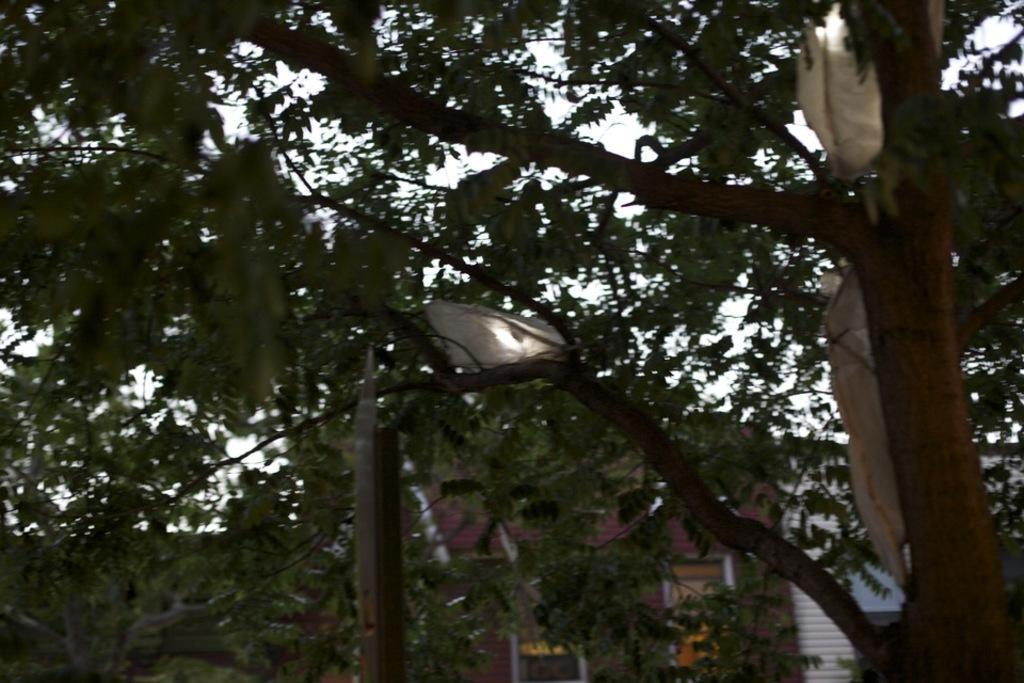What is the main object in the image? There is a pole in the image. What is covering the branches of the tree in the image? There are polythene covers on the branches of a tree. What can be seen in the distance in the image? There are houses visible in the background of the image. What is visible above the houses in the image? The sky is visible in the background of the image. Can you tell me how many baseballs are on the pole in the image? There are no baseballs present in the image; it only features a pole and polythene covers on a tree. Is the queen visible in the image? There is no queen present in the image. 